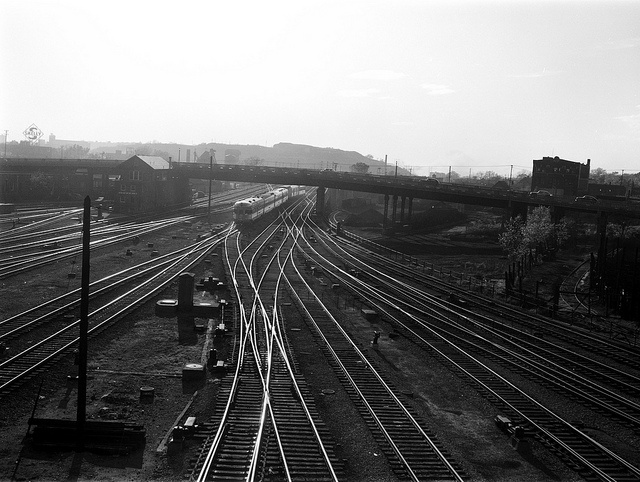Describe the objects in this image and their specific colors. I can see train in white, gray, darkgray, black, and lightgray tones, car in black, gray, and white tones, car in black, gray, and white tones, car in darkgray, gray, black, and white tones, and car in black, gray, and white tones in this image. 